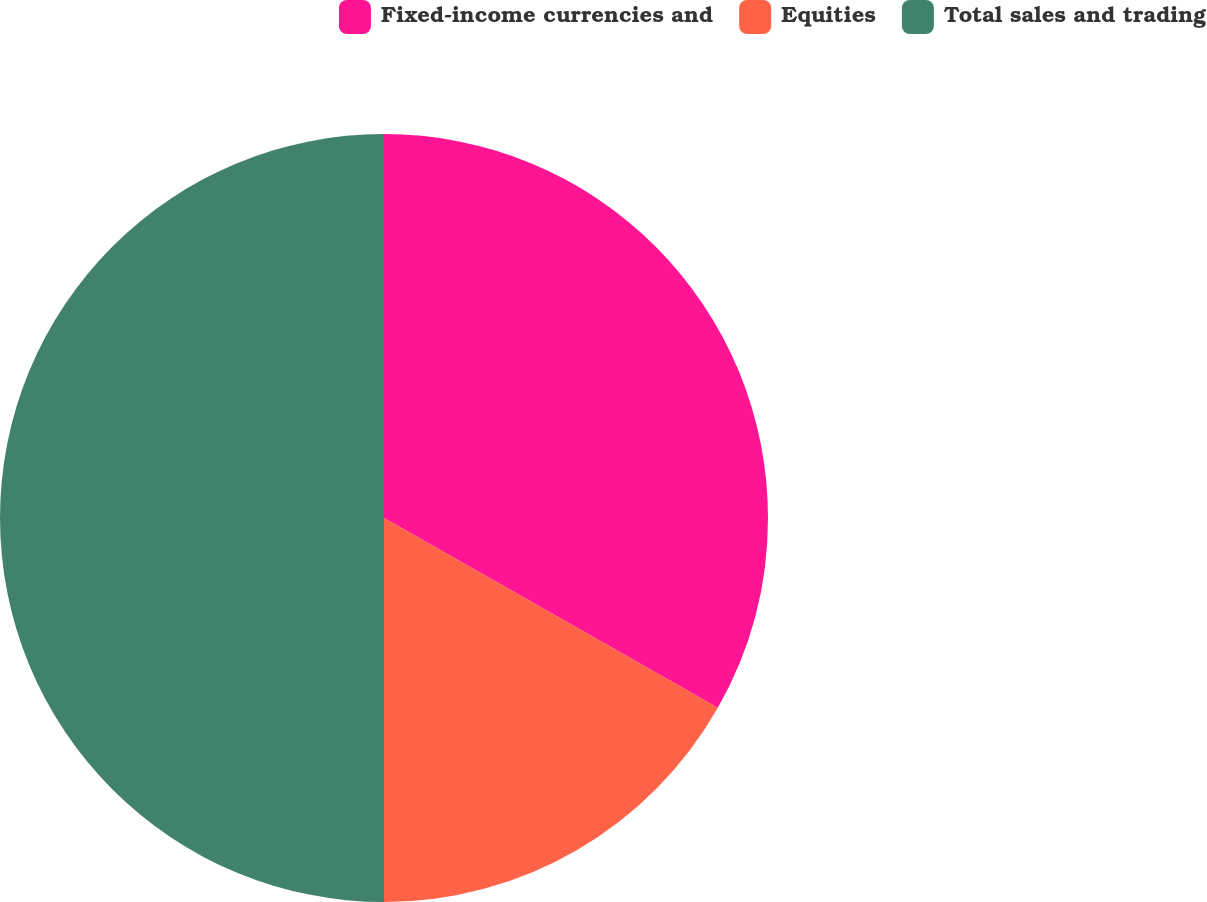Convert chart to OTSL. <chart><loc_0><loc_0><loc_500><loc_500><pie_chart><fcel>Fixed-income currencies and<fcel>Equities<fcel>Total sales and trading<nl><fcel>33.23%<fcel>16.77%<fcel>50.0%<nl></chart> 